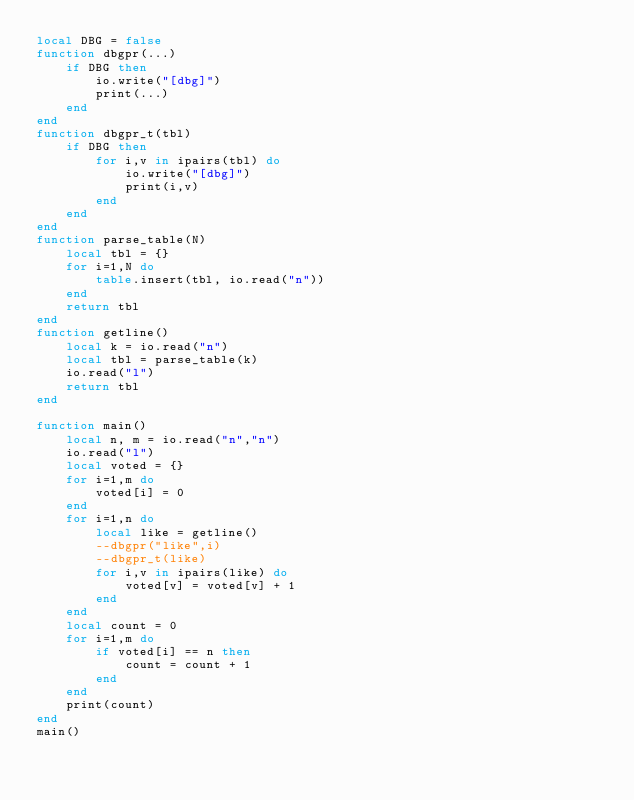Convert code to text. <code><loc_0><loc_0><loc_500><loc_500><_Lua_>local DBG = false
function dbgpr(...)
    if DBG then
        io.write("[dbg]")
        print(...)
    end
end
function dbgpr_t(tbl)
    if DBG then
        for i,v in ipairs(tbl) do
            io.write("[dbg]")
            print(i,v)
        end
    end
end
function parse_table(N)
    local tbl = {}
    for i=1,N do
        table.insert(tbl, io.read("n"))
    end
    return tbl
end
function getline()
    local k = io.read("n")
    local tbl = parse_table(k)
    io.read("l")
    return tbl
end

function main()
    local n, m = io.read("n","n")
    io.read("l")
    local voted = {}
    for i=1,m do
        voted[i] = 0
    end
    for i=1,n do
        local like = getline()
        --dbgpr("like",i)
        --dbgpr_t(like)
        for i,v in ipairs(like) do
            voted[v] = voted[v] + 1
        end
    end
    local count = 0
    for i=1,m do
        if voted[i] == n then
            count = count + 1
        end
    end
    print(count)
end
main()
</code> 